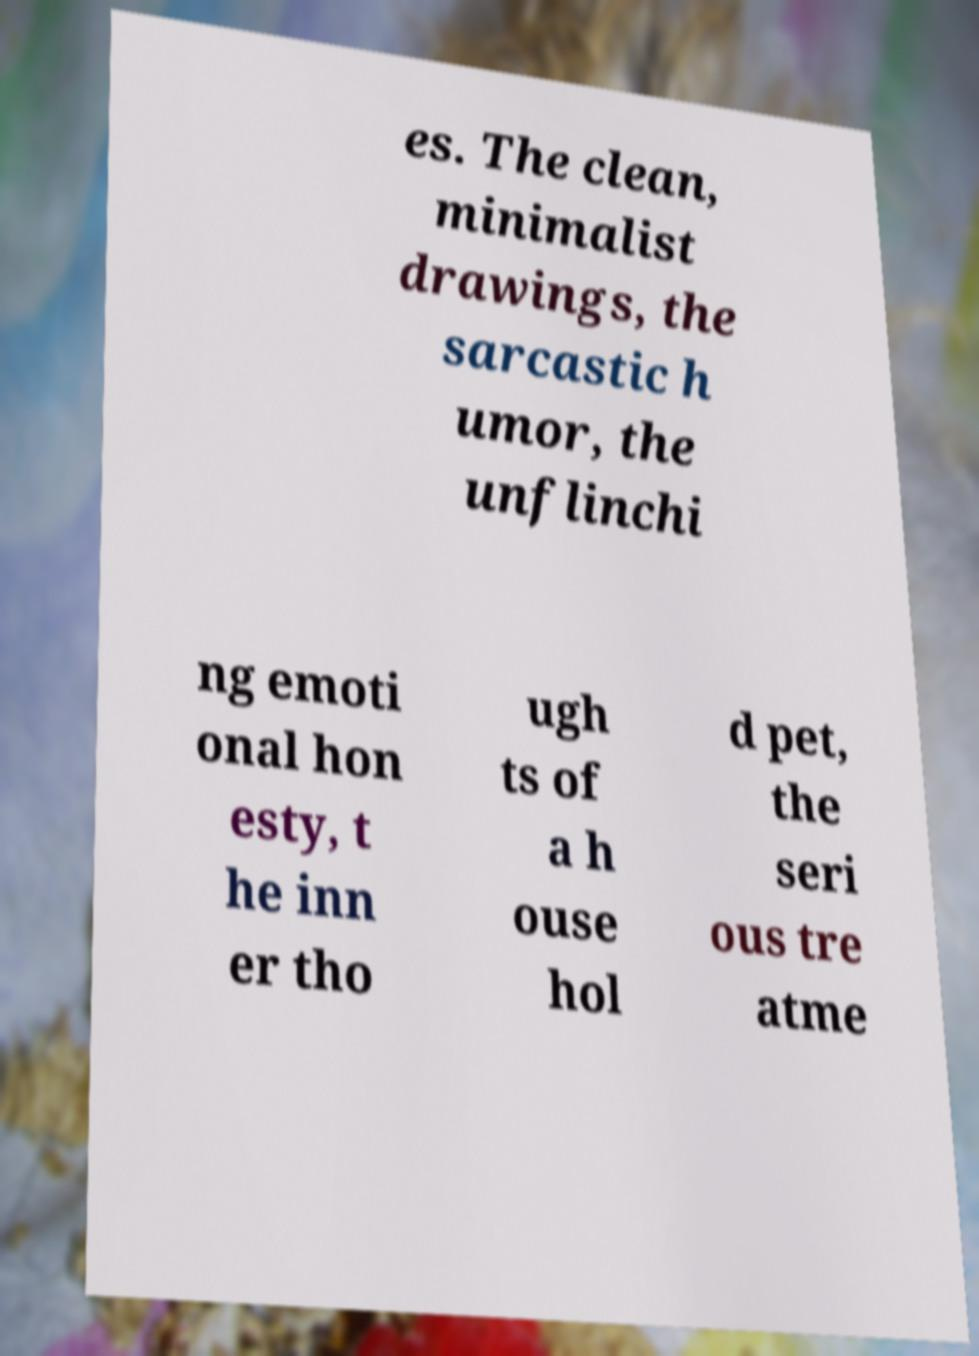Can you accurately transcribe the text from the provided image for me? es. The clean, minimalist drawings, the sarcastic h umor, the unflinchi ng emoti onal hon esty, t he inn er tho ugh ts of a h ouse hol d pet, the seri ous tre atme 